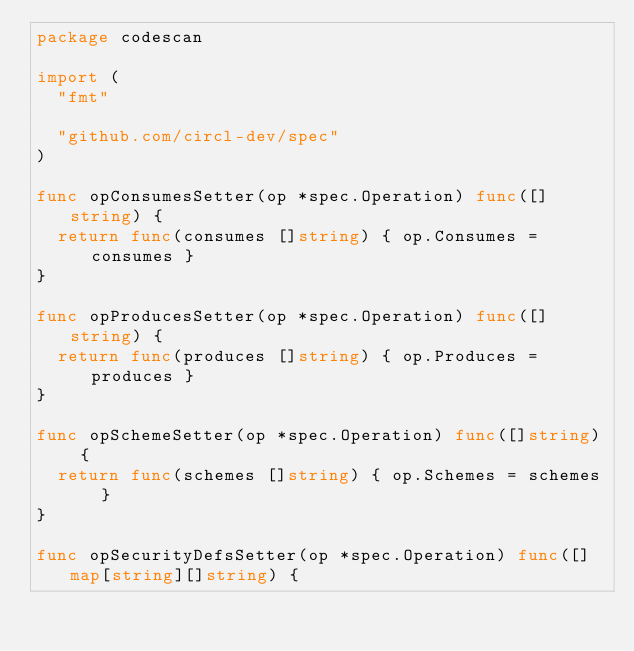<code> <loc_0><loc_0><loc_500><loc_500><_Go_>package codescan

import (
	"fmt"

	"github.com/circl-dev/spec"
)

func opConsumesSetter(op *spec.Operation) func([]string) {
	return func(consumes []string) { op.Consumes = consumes }
}

func opProducesSetter(op *spec.Operation) func([]string) {
	return func(produces []string) { op.Produces = produces }
}

func opSchemeSetter(op *spec.Operation) func([]string) {
	return func(schemes []string) { op.Schemes = schemes }
}

func opSecurityDefsSetter(op *spec.Operation) func([]map[string][]string) {</code> 